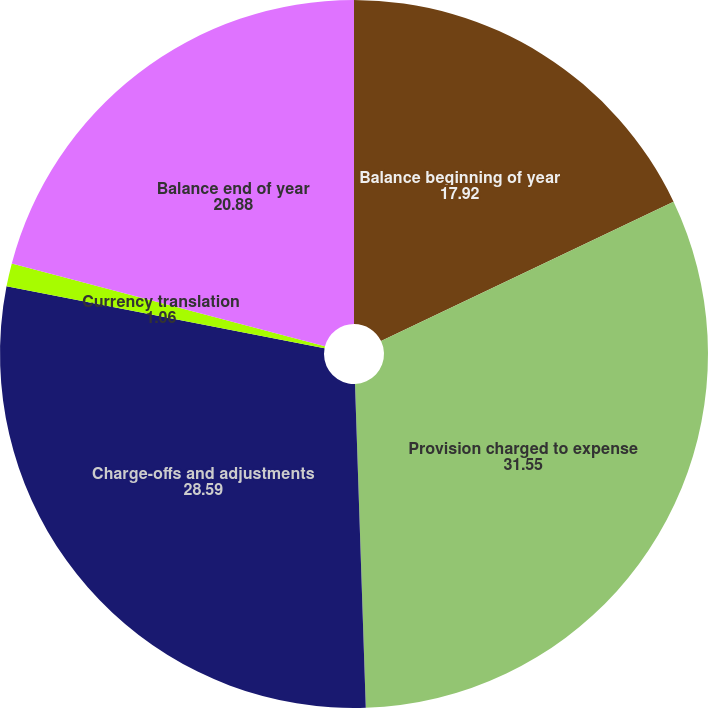Convert chart. <chart><loc_0><loc_0><loc_500><loc_500><pie_chart><fcel>Balance beginning of year<fcel>Provision charged to expense<fcel>Charge-offs and adjustments<fcel>Currency translation<fcel>Balance end of year<nl><fcel>17.92%<fcel>31.55%<fcel>28.59%<fcel>1.06%<fcel>20.88%<nl></chart> 